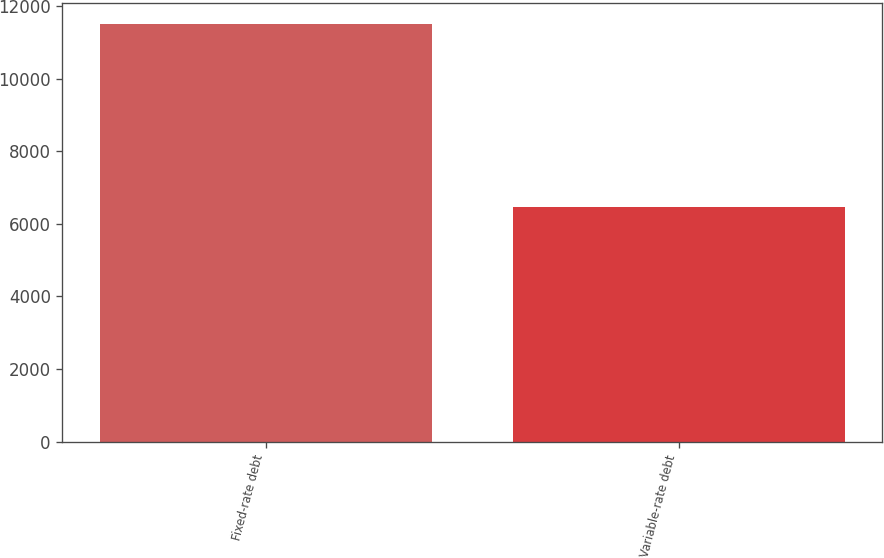<chart> <loc_0><loc_0><loc_500><loc_500><bar_chart><fcel>Fixed-rate debt<fcel>Variable-rate debt<nl><fcel>11508<fcel>6455<nl></chart> 